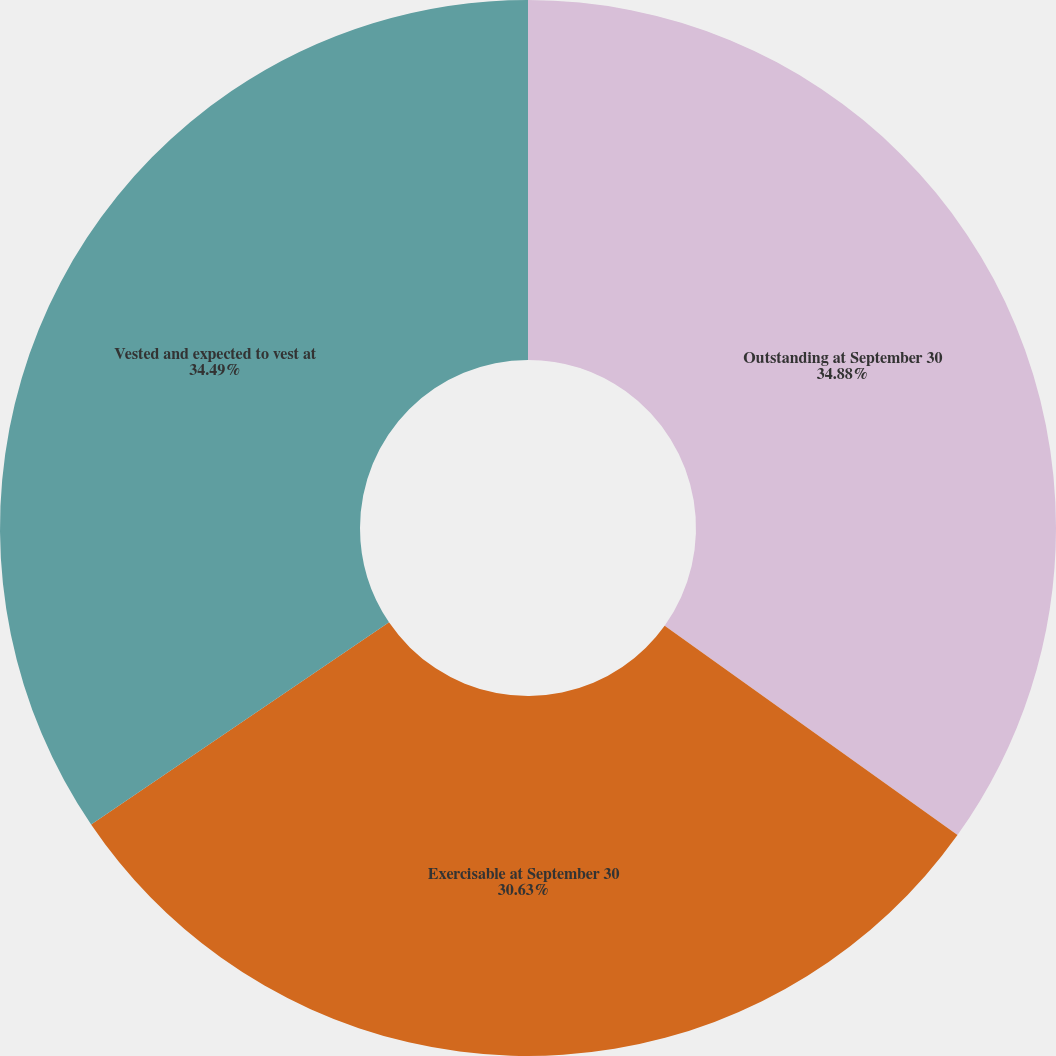Convert chart. <chart><loc_0><loc_0><loc_500><loc_500><pie_chart><fcel>Outstanding at September 30<fcel>Exercisable at September 30<fcel>Vested and expected to vest at<nl><fcel>34.88%<fcel>30.63%<fcel>34.49%<nl></chart> 